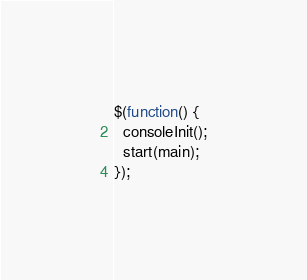Convert code to text. <code><loc_0><loc_0><loc_500><loc_500><_JavaScript_>$(function() {
  consoleInit();
  start(main);
});
</code> 